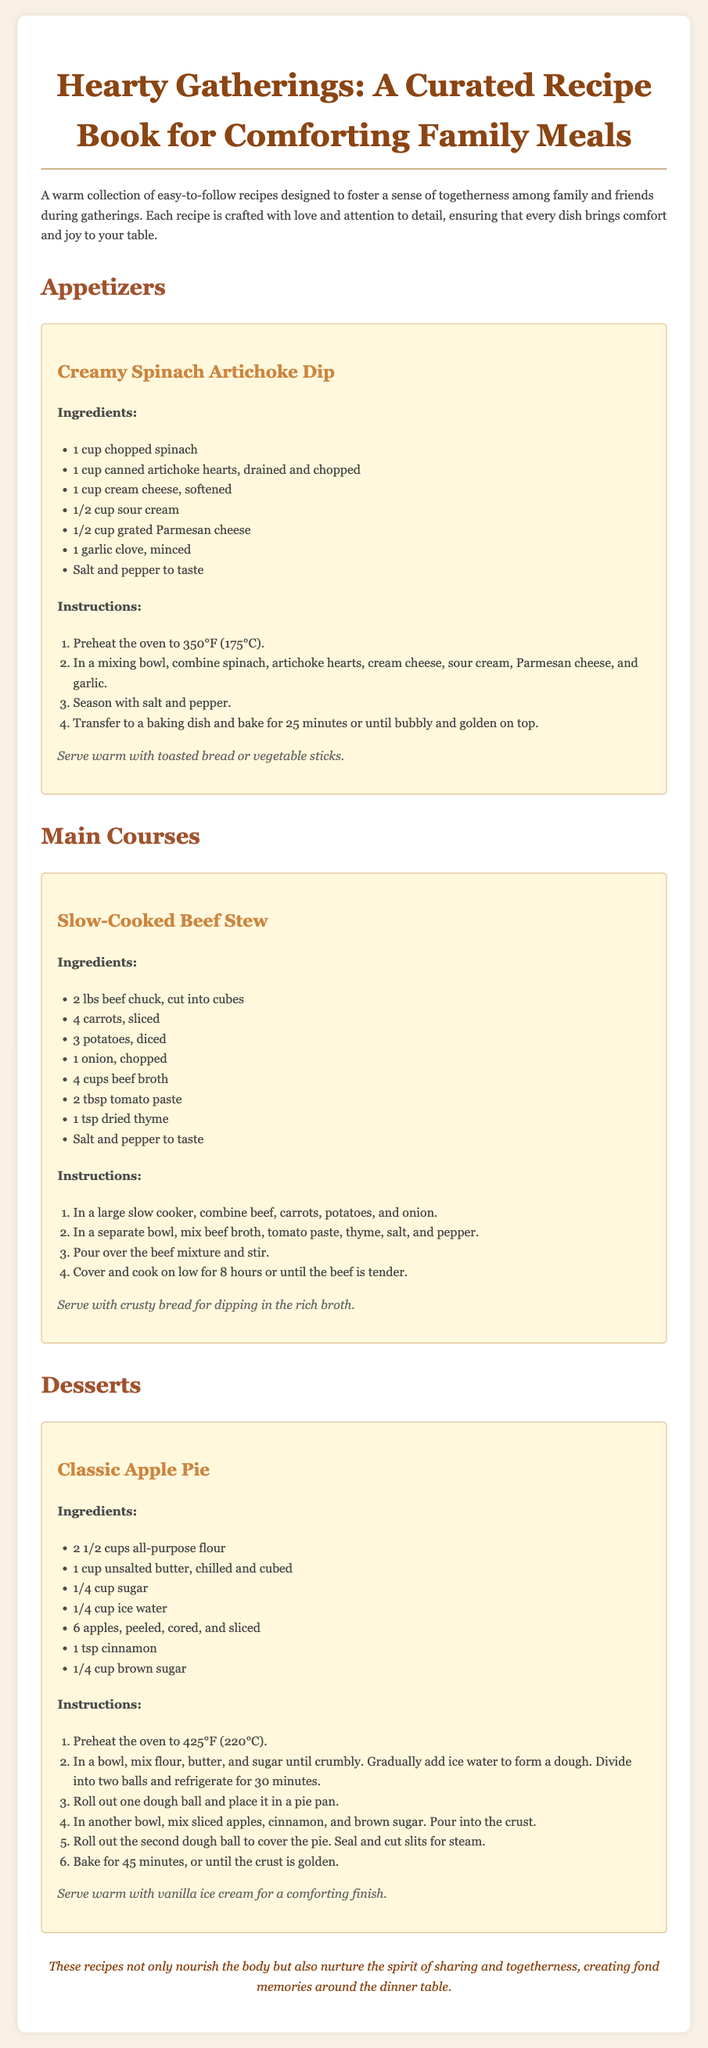What is the title of the recipe book? The title is prominently displayed at the top of the document as the main heading.
Answer: Hearty Gatherings: A Curated Recipe Book for Comforting Family Meals How many main courses are listed? The document contains a section specifically for main courses, and it includes one recipe listed under that section.
Answer: 1 What is one of the ingredients in the Classic Apple Pie recipe? The ingredient list is provided for each recipe, and it specifies key items used in the Classic Apple Pie.
Answer: apples What is the cooking time for the Slow-Cooked Beef Stew? The instructions for the Slow-Cooked Beef Stew specify the duration of cooking.
Answer: 8 hours What should be served with the Creamy Spinach Artichoke Dip? The serving suggestion for the Creamy Spinach Artichoke Dip includes specific items to accompany the dish.
Answer: toasted bread or vegetable sticks What type of dish is the Creamy Spinach Artichoke Dip categorized under? The recipe is listed in a specific section dedicated to starters and appetizers in the document.
Answer: Appetizers What is the main purpose of the recipes in this book? The introductory paragraph states the overall aim of the recipes provided within the book.
Answer: foster a sense of togetherness What should be served with the Classic Apple Pie for a comforting finish? The serving suggestion for the Classic Apple Pie includes a specific accompaniment mentioned in the recipe.
Answer: vanilla ice cream 